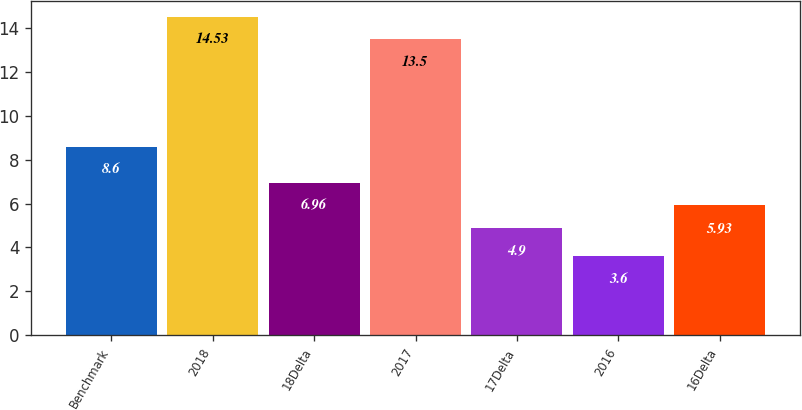Convert chart. <chart><loc_0><loc_0><loc_500><loc_500><bar_chart><fcel>Benchmark<fcel>2018<fcel>18Delta<fcel>2017<fcel>17Delta<fcel>2016<fcel>16Delta<nl><fcel>8.6<fcel>14.53<fcel>6.96<fcel>13.5<fcel>4.9<fcel>3.6<fcel>5.93<nl></chart> 